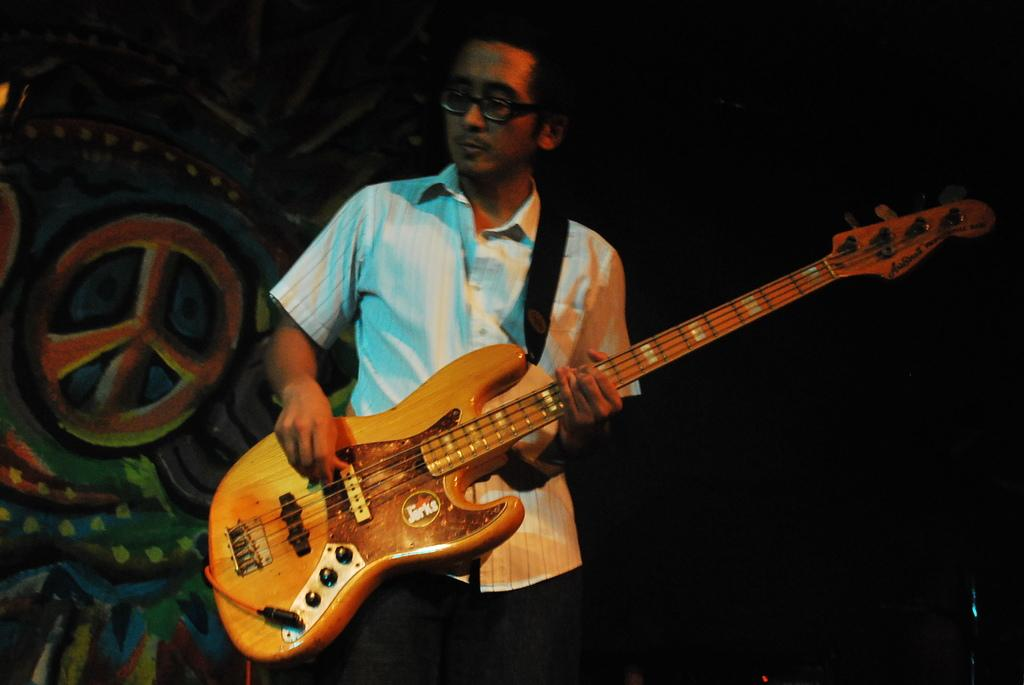Who is the main subject in the image? There is a man in the image. Where is the man located in the image? The man is at the center of the image. What is the man holding in his hand? The man is holding a guitar in his hand. What can be seen on the left side of the image? There is a poster on the left side of the image. What type of music can be heard coming from the cars in the image? There are no cars present in the image, so it's not possible to determine what, if any, music might be heard. 